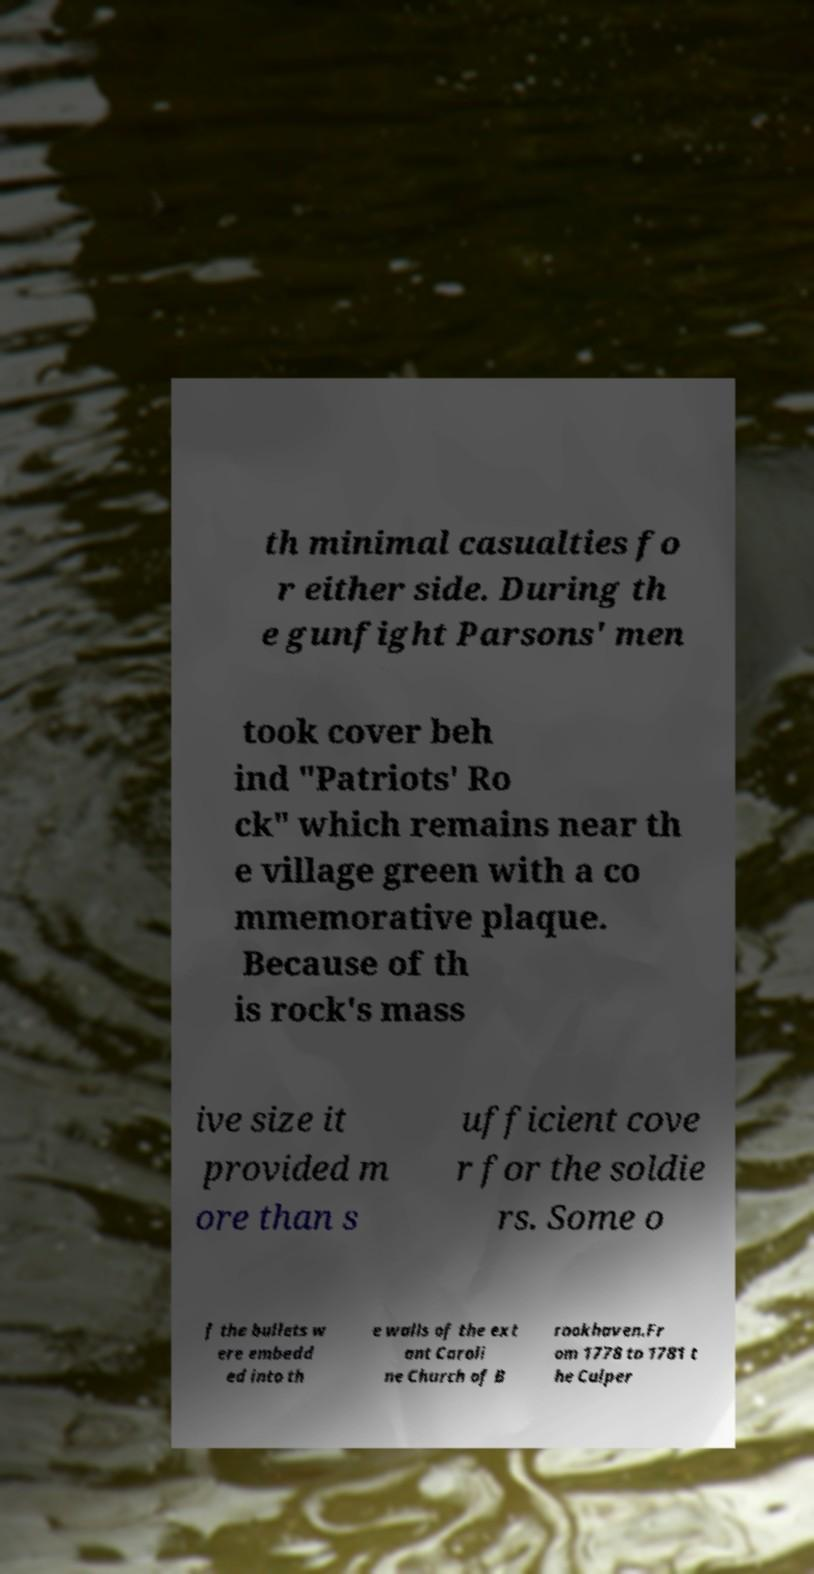I need the written content from this picture converted into text. Can you do that? th minimal casualties fo r either side. During th e gunfight Parsons' men took cover beh ind "Patriots' Ro ck" which remains near th e village green with a co mmemorative plaque. Because of th is rock's mass ive size it provided m ore than s ufficient cove r for the soldie rs. Some o f the bullets w ere embedd ed into th e walls of the ext ant Caroli ne Church of B rookhaven.Fr om 1778 to 1781 t he Culper 